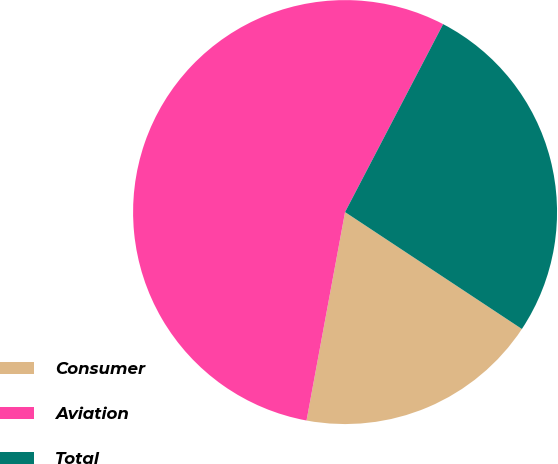<chart> <loc_0><loc_0><loc_500><loc_500><pie_chart><fcel>Consumer<fcel>Aviation<fcel>Total<nl><fcel>18.61%<fcel>54.74%<fcel>26.64%<nl></chart> 